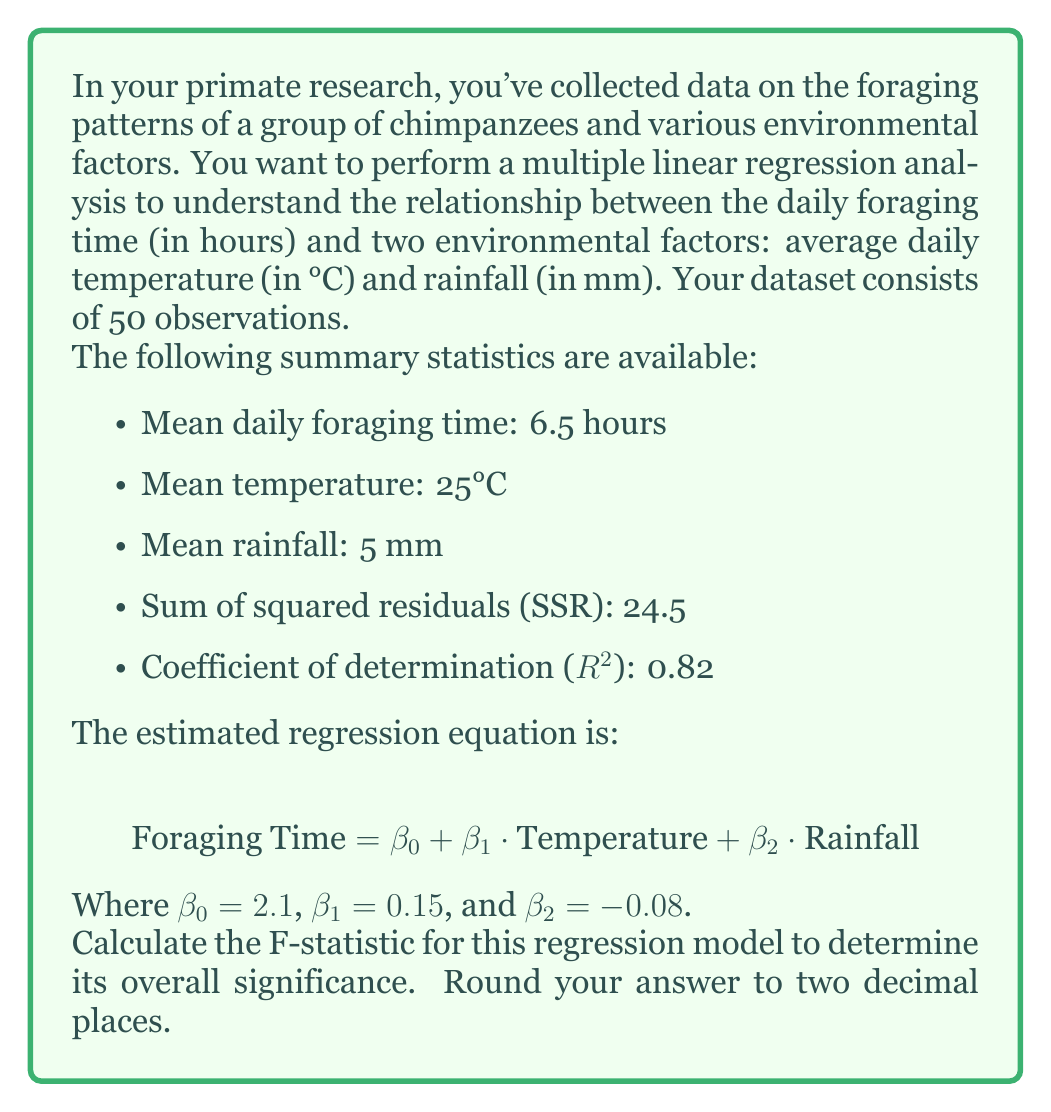What is the answer to this math problem? To calculate the F-statistic for this multiple linear regression model, we'll follow these steps:

1) The F-statistic is calculated using the formula:

   $$ F = \frac{R^2 / k}{(1 - R^2) / (n - k - 1)} $$

   Where:
   - $R^2$ is the coefficient of determination
   - $k$ is the number of independent variables
   - $n$ is the number of observations

2) We're given:
   - $R^2 = 0.82$
   - $k = 2$ (temperature and rainfall)
   - $n = 50$

3) Let's substitute these values into the formula:

   $$ F = \frac{0.82 / 2}{(1 - 0.82) / (50 - 2 - 1)} $$

4) Simplify the numerator and denominator:
   
   $$ F = \frac{0.41}{0.18 / 47} $$

5) Divide:
   
   $$ F = \frac{0.41}{0.003830} $$

6) Calculate the final result:
   
   $$ F \approx 107.05 $$

7) Rounding to two decimal places:
   
   $$ F \approx 107.05 $$

This F-statistic can be used to test the null hypothesis that all of the regression coefficients are zero. A large F-statistic, as we have here, suggests that the regression model is significant.
Answer: $$ F \approx 107.05 $$ 